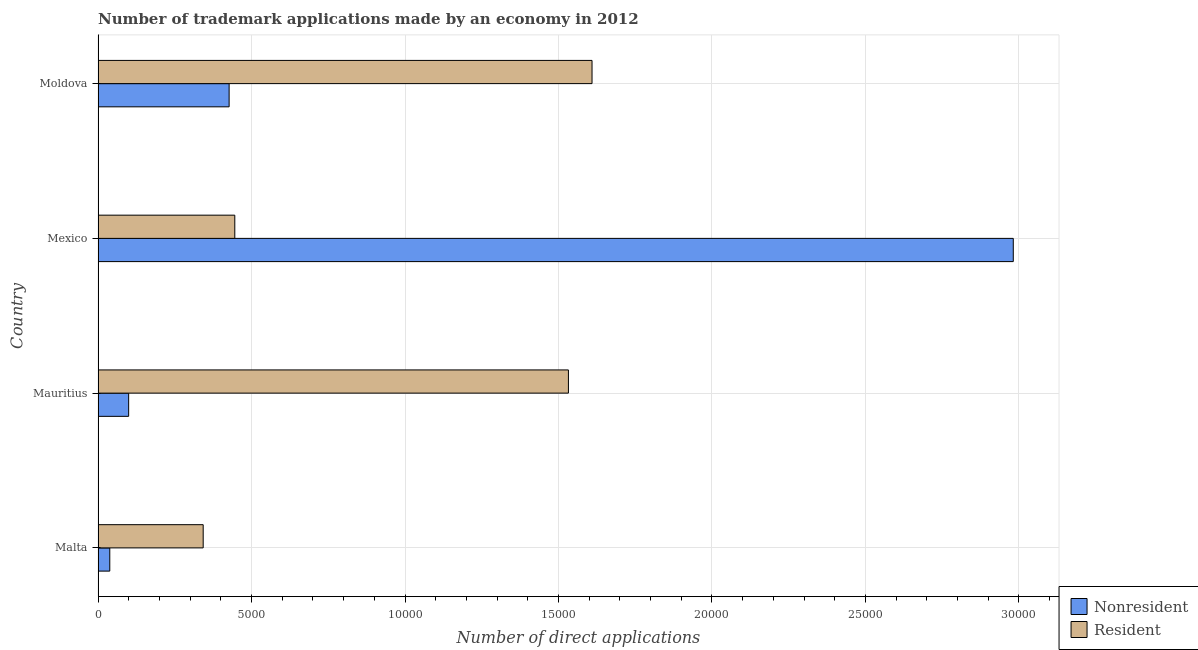How many different coloured bars are there?
Your answer should be compact. 2. How many groups of bars are there?
Provide a short and direct response. 4. Are the number of bars per tick equal to the number of legend labels?
Your answer should be very brief. Yes. How many bars are there on the 4th tick from the top?
Keep it short and to the point. 2. How many bars are there on the 1st tick from the bottom?
Offer a very short reply. 2. What is the label of the 3rd group of bars from the top?
Offer a very short reply. Mauritius. In how many cases, is the number of bars for a given country not equal to the number of legend labels?
Provide a short and direct response. 0. What is the number of trademark applications made by residents in Mauritius?
Provide a succinct answer. 1.53e+04. Across all countries, what is the maximum number of trademark applications made by residents?
Provide a short and direct response. 1.61e+04. Across all countries, what is the minimum number of trademark applications made by residents?
Offer a very short reply. 3425. In which country was the number of trademark applications made by residents maximum?
Ensure brevity in your answer.  Moldova. In which country was the number of trademark applications made by residents minimum?
Your answer should be very brief. Malta. What is the total number of trademark applications made by non residents in the graph?
Ensure brevity in your answer.  3.55e+04. What is the difference between the number of trademark applications made by residents in Malta and that in Mauritius?
Offer a very short reply. -1.19e+04. What is the difference between the number of trademark applications made by residents in Malta and the number of trademark applications made by non residents in Mauritius?
Make the answer very short. 2428. What is the average number of trademark applications made by residents per country?
Keep it short and to the point. 9823.75. What is the difference between the number of trademark applications made by non residents and number of trademark applications made by residents in Moldova?
Offer a terse response. -1.18e+04. What is the ratio of the number of trademark applications made by residents in Malta to that in Mexico?
Ensure brevity in your answer.  0.77. Is the difference between the number of trademark applications made by residents in Malta and Mauritius greater than the difference between the number of trademark applications made by non residents in Malta and Mauritius?
Offer a very short reply. No. What is the difference between the highest and the second highest number of trademark applications made by non residents?
Make the answer very short. 2.55e+04. What is the difference between the highest and the lowest number of trademark applications made by non residents?
Provide a short and direct response. 2.94e+04. In how many countries, is the number of trademark applications made by non residents greater than the average number of trademark applications made by non residents taken over all countries?
Offer a very short reply. 1. Is the sum of the number of trademark applications made by residents in Malta and Moldova greater than the maximum number of trademark applications made by non residents across all countries?
Make the answer very short. No. What does the 2nd bar from the top in Mexico represents?
Offer a very short reply. Nonresident. What does the 2nd bar from the bottom in Moldova represents?
Offer a very short reply. Resident. How many countries are there in the graph?
Your response must be concise. 4. What is the difference between two consecutive major ticks on the X-axis?
Ensure brevity in your answer.  5000. Are the values on the major ticks of X-axis written in scientific E-notation?
Make the answer very short. No. Does the graph contain any zero values?
Your answer should be compact. No. How many legend labels are there?
Keep it short and to the point. 2. What is the title of the graph?
Provide a succinct answer. Number of trademark applications made by an economy in 2012. Does "Netherlands" appear as one of the legend labels in the graph?
Give a very brief answer. No. What is the label or title of the X-axis?
Offer a terse response. Number of direct applications. What is the label or title of the Y-axis?
Offer a terse response. Country. What is the Number of direct applications in Nonresident in Malta?
Offer a very short reply. 382. What is the Number of direct applications in Resident in Malta?
Keep it short and to the point. 3425. What is the Number of direct applications of Nonresident in Mauritius?
Keep it short and to the point. 997. What is the Number of direct applications in Resident in Mauritius?
Offer a very short reply. 1.53e+04. What is the Number of direct applications in Nonresident in Mexico?
Provide a short and direct response. 2.98e+04. What is the Number of direct applications in Resident in Mexico?
Give a very brief answer. 4455. What is the Number of direct applications in Nonresident in Moldova?
Your response must be concise. 4270. What is the Number of direct applications in Resident in Moldova?
Your answer should be very brief. 1.61e+04. Across all countries, what is the maximum Number of direct applications of Nonresident?
Offer a very short reply. 2.98e+04. Across all countries, what is the maximum Number of direct applications in Resident?
Offer a terse response. 1.61e+04. Across all countries, what is the minimum Number of direct applications of Nonresident?
Your response must be concise. 382. Across all countries, what is the minimum Number of direct applications in Resident?
Your answer should be compact. 3425. What is the total Number of direct applications of Nonresident in the graph?
Keep it short and to the point. 3.55e+04. What is the total Number of direct applications in Resident in the graph?
Ensure brevity in your answer.  3.93e+04. What is the difference between the Number of direct applications of Nonresident in Malta and that in Mauritius?
Make the answer very short. -615. What is the difference between the Number of direct applications in Resident in Malta and that in Mauritius?
Offer a very short reply. -1.19e+04. What is the difference between the Number of direct applications in Nonresident in Malta and that in Mexico?
Ensure brevity in your answer.  -2.94e+04. What is the difference between the Number of direct applications in Resident in Malta and that in Mexico?
Provide a succinct answer. -1030. What is the difference between the Number of direct applications in Nonresident in Malta and that in Moldova?
Make the answer very short. -3888. What is the difference between the Number of direct applications of Resident in Malta and that in Moldova?
Your response must be concise. -1.27e+04. What is the difference between the Number of direct applications of Nonresident in Mauritius and that in Mexico?
Your answer should be compact. -2.88e+04. What is the difference between the Number of direct applications of Resident in Mauritius and that in Mexico?
Your answer should be very brief. 1.09e+04. What is the difference between the Number of direct applications of Nonresident in Mauritius and that in Moldova?
Offer a very short reply. -3273. What is the difference between the Number of direct applications in Resident in Mauritius and that in Moldova?
Provide a short and direct response. -769. What is the difference between the Number of direct applications of Nonresident in Mexico and that in Moldova?
Give a very brief answer. 2.55e+04. What is the difference between the Number of direct applications in Resident in Mexico and that in Moldova?
Ensure brevity in your answer.  -1.16e+04. What is the difference between the Number of direct applications of Nonresident in Malta and the Number of direct applications of Resident in Mauritius?
Provide a short and direct response. -1.49e+04. What is the difference between the Number of direct applications of Nonresident in Malta and the Number of direct applications of Resident in Mexico?
Provide a short and direct response. -4073. What is the difference between the Number of direct applications in Nonresident in Malta and the Number of direct applications in Resident in Moldova?
Offer a terse response. -1.57e+04. What is the difference between the Number of direct applications in Nonresident in Mauritius and the Number of direct applications in Resident in Mexico?
Provide a short and direct response. -3458. What is the difference between the Number of direct applications in Nonresident in Mauritius and the Number of direct applications in Resident in Moldova?
Ensure brevity in your answer.  -1.51e+04. What is the difference between the Number of direct applications of Nonresident in Mexico and the Number of direct applications of Resident in Moldova?
Provide a succinct answer. 1.37e+04. What is the average Number of direct applications in Nonresident per country?
Keep it short and to the point. 8866. What is the average Number of direct applications of Resident per country?
Offer a terse response. 9823.75. What is the difference between the Number of direct applications in Nonresident and Number of direct applications in Resident in Malta?
Make the answer very short. -3043. What is the difference between the Number of direct applications of Nonresident and Number of direct applications of Resident in Mauritius?
Your answer should be compact. -1.43e+04. What is the difference between the Number of direct applications in Nonresident and Number of direct applications in Resident in Mexico?
Provide a short and direct response. 2.54e+04. What is the difference between the Number of direct applications in Nonresident and Number of direct applications in Resident in Moldova?
Keep it short and to the point. -1.18e+04. What is the ratio of the Number of direct applications of Nonresident in Malta to that in Mauritius?
Ensure brevity in your answer.  0.38. What is the ratio of the Number of direct applications in Resident in Malta to that in Mauritius?
Keep it short and to the point. 0.22. What is the ratio of the Number of direct applications of Nonresident in Malta to that in Mexico?
Provide a succinct answer. 0.01. What is the ratio of the Number of direct applications in Resident in Malta to that in Mexico?
Ensure brevity in your answer.  0.77. What is the ratio of the Number of direct applications of Nonresident in Malta to that in Moldova?
Your answer should be compact. 0.09. What is the ratio of the Number of direct applications in Resident in Malta to that in Moldova?
Ensure brevity in your answer.  0.21. What is the ratio of the Number of direct applications in Nonresident in Mauritius to that in Mexico?
Ensure brevity in your answer.  0.03. What is the ratio of the Number of direct applications of Resident in Mauritius to that in Mexico?
Keep it short and to the point. 3.44. What is the ratio of the Number of direct applications in Nonresident in Mauritius to that in Moldova?
Your answer should be compact. 0.23. What is the ratio of the Number of direct applications in Resident in Mauritius to that in Moldova?
Offer a terse response. 0.95. What is the ratio of the Number of direct applications of Nonresident in Mexico to that in Moldova?
Offer a very short reply. 6.98. What is the ratio of the Number of direct applications of Resident in Mexico to that in Moldova?
Your answer should be very brief. 0.28. What is the difference between the highest and the second highest Number of direct applications of Nonresident?
Offer a terse response. 2.55e+04. What is the difference between the highest and the second highest Number of direct applications of Resident?
Offer a terse response. 769. What is the difference between the highest and the lowest Number of direct applications of Nonresident?
Ensure brevity in your answer.  2.94e+04. What is the difference between the highest and the lowest Number of direct applications of Resident?
Provide a short and direct response. 1.27e+04. 